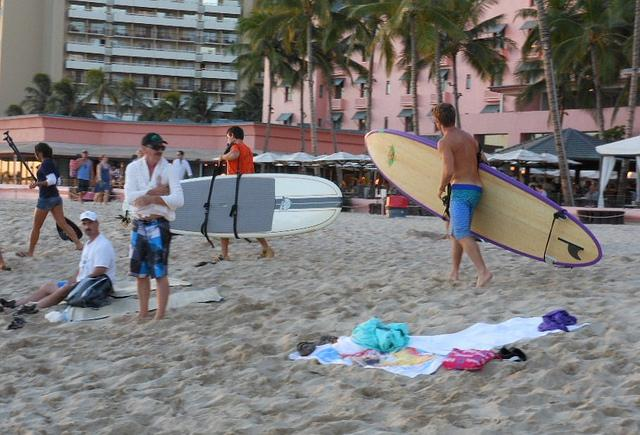What type of trees can be seen near the pink building? palm 